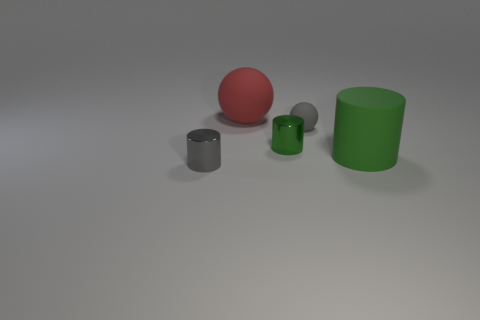Add 1 small green metal cylinders. How many objects exist? 6 Subtract all spheres. How many objects are left? 3 Add 1 tiny blue cylinders. How many tiny blue cylinders exist? 1 Subtract all gray cylinders. How many cylinders are left? 2 Subtract all small cylinders. How many cylinders are left? 1 Subtract 0 purple cylinders. How many objects are left? 5 Subtract 1 spheres. How many spheres are left? 1 Subtract all blue cylinders. Subtract all cyan blocks. How many cylinders are left? 3 Subtract all red blocks. How many red cylinders are left? 0 Subtract all large cylinders. Subtract all large green objects. How many objects are left? 3 